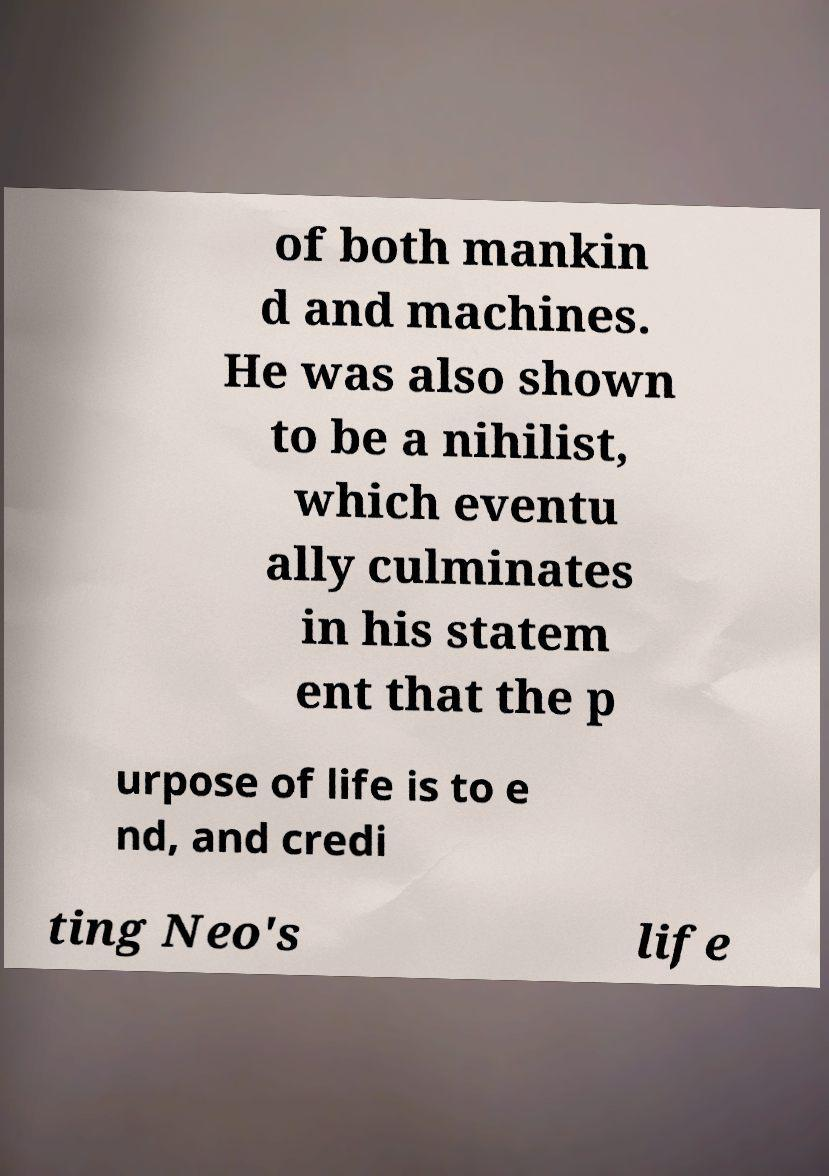Could you assist in decoding the text presented in this image and type it out clearly? of both mankin d and machines. He was also shown to be a nihilist, which eventu ally culminates in his statem ent that the p urpose of life is to e nd, and credi ting Neo's life 